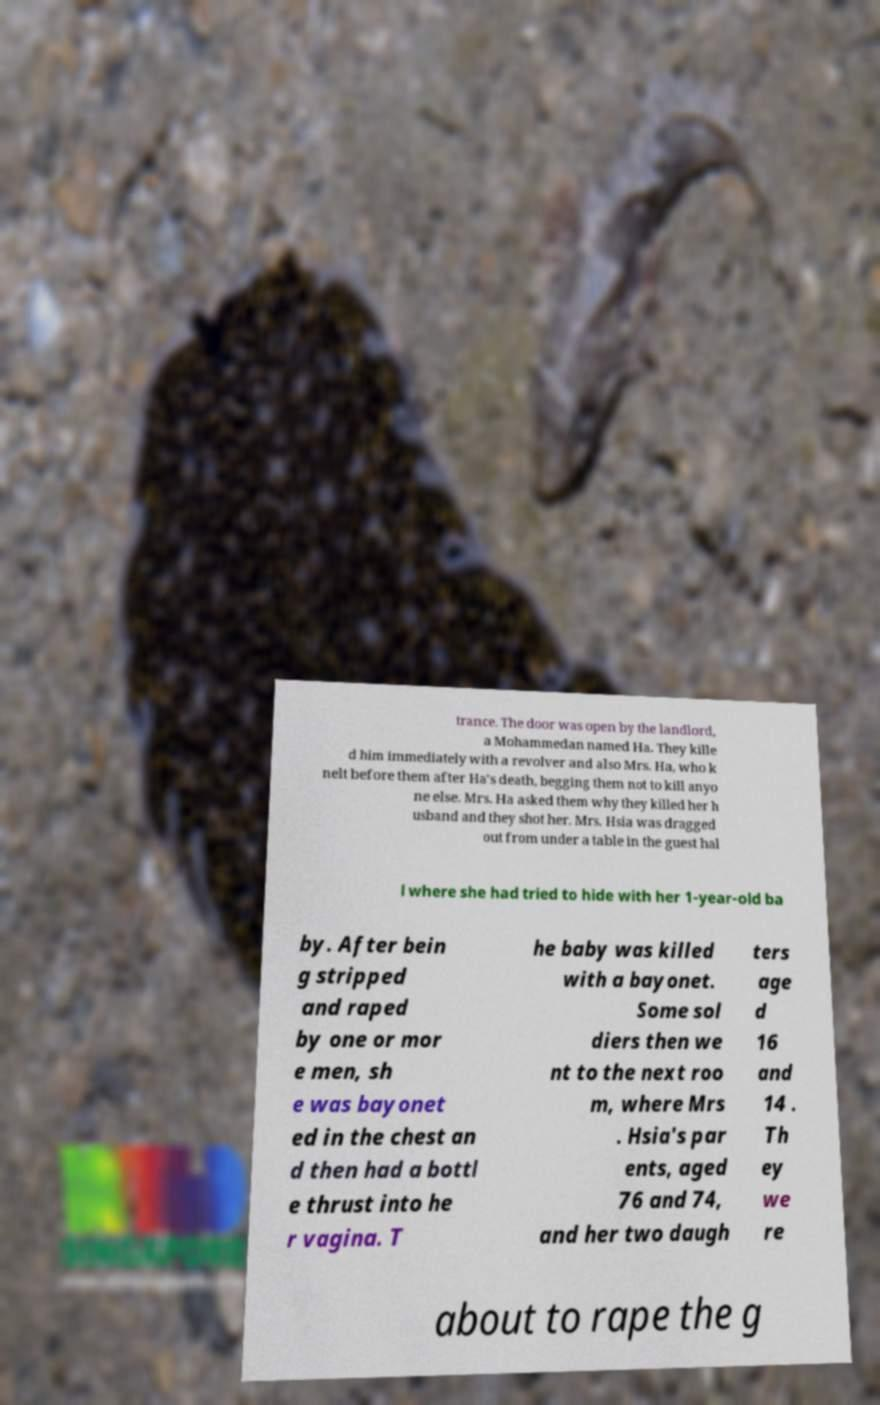Could you extract and type out the text from this image? trance. The door was open by the landlord, a Mohammedan named Ha. They kille d him immediately with a revolver and also Mrs. Ha, who k nelt before them after Ha's death, begging them not to kill anyo ne else. Mrs. Ha asked them why they killed her h usband and they shot her. Mrs. Hsia was dragged out from under a table in the guest hal l where she had tried to hide with her 1-year-old ba by. After bein g stripped and raped by one or mor e men, sh e was bayonet ed in the chest an d then had a bottl e thrust into he r vagina. T he baby was killed with a bayonet. Some sol diers then we nt to the next roo m, where Mrs . Hsia's par ents, aged 76 and 74, and her two daugh ters age d 16 and 14 . Th ey we re about to rape the g 